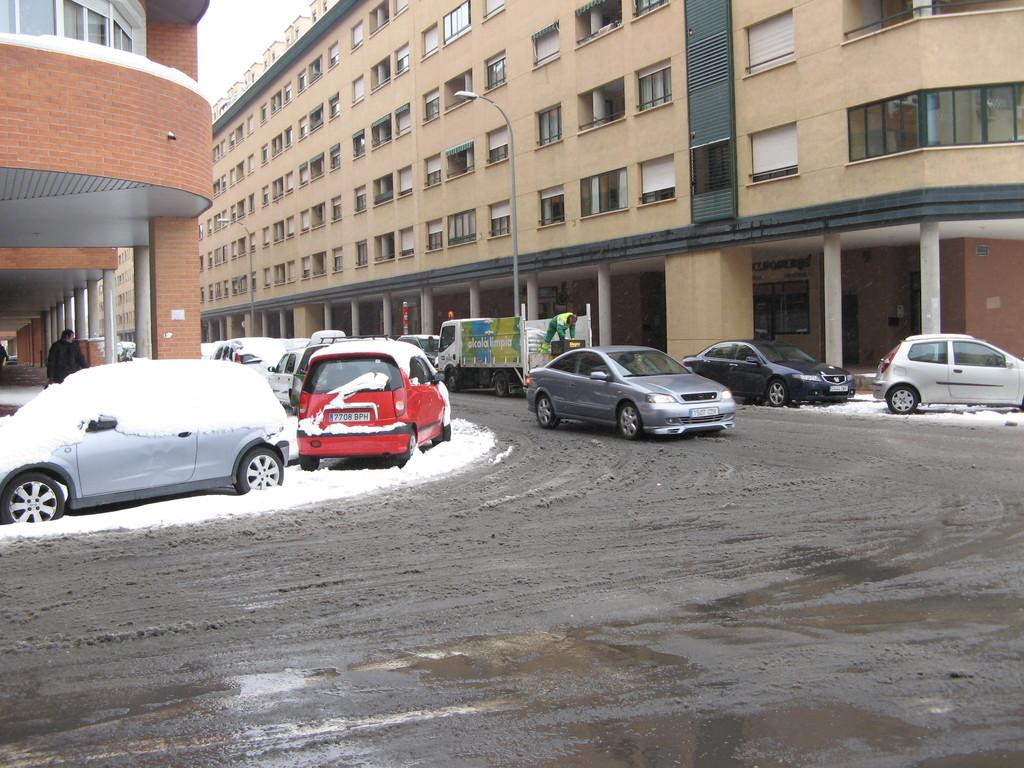What can be seen on the road in the image? There are cars on the road in the image. What is located on either side of the road? There are buildings on either side of the road in the image. What feature do the buildings have? The buildings have many windows. Can you see a branch hanging from the zipper in the image? There is no branch or zipper present in the image. What type of loss is depicted in the image? There is no loss depicted in the image; it features cars on the road and buildings with windows. 